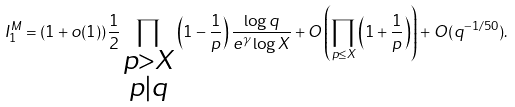Convert formula to latex. <formula><loc_0><loc_0><loc_500><loc_500>I _ { 1 } ^ { M } = ( 1 + o ( 1 ) ) \frac { 1 } { 2 } \prod _ { \substack { p > X \\ p | q } } \left ( 1 - \frac { 1 } { p } \right ) \frac { \log q } { e ^ { \gamma } \log X } + O \left ( \prod _ { p \leq X } \left ( 1 + \frac { 1 } { p } \right ) \right ) + O ( q ^ { - 1 / 5 0 } ) .</formula> 